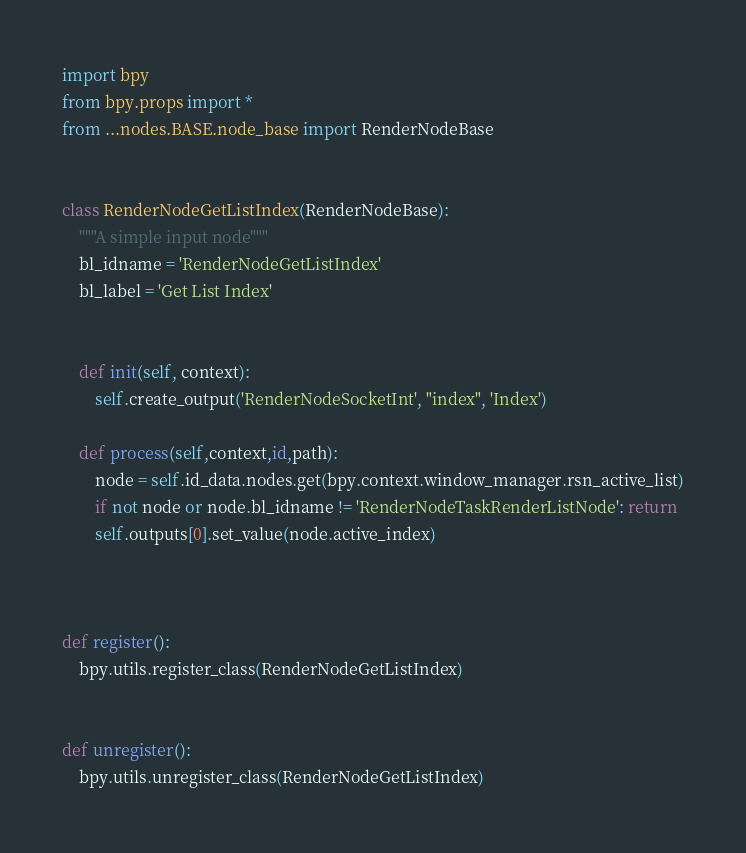Convert code to text. <code><loc_0><loc_0><loc_500><loc_500><_Python_>import bpy
from bpy.props import *
from ...nodes.BASE.node_base import RenderNodeBase


class RenderNodeGetListIndex(RenderNodeBase):
    """A simple input node"""
    bl_idname = 'RenderNodeGetListIndex'
    bl_label = 'Get List Index'


    def init(self, context):
        self.create_output('RenderNodeSocketInt', "index", 'Index')

    def process(self,context,id,path):
        node = self.id_data.nodes.get(bpy.context.window_manager.rsn_active_list)
        if not node or node.bl_idname != 'RenderNodeTaskRenderListNode': return
        self.outputs[0].set_value(node.active_index)



def register():
    bpy.utils.register_class(RenderNodeGetListIndex)


def unregister():
    bpy.utils.unregister_class(RenderNodeGetListIndex)
</code> 